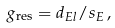Convert formula to latex. <formula><loc_0><loc_0><loc_500><loc_500>g _ { \text {res} } = d _ { E l } / s _ { E } \, ,</formula> 